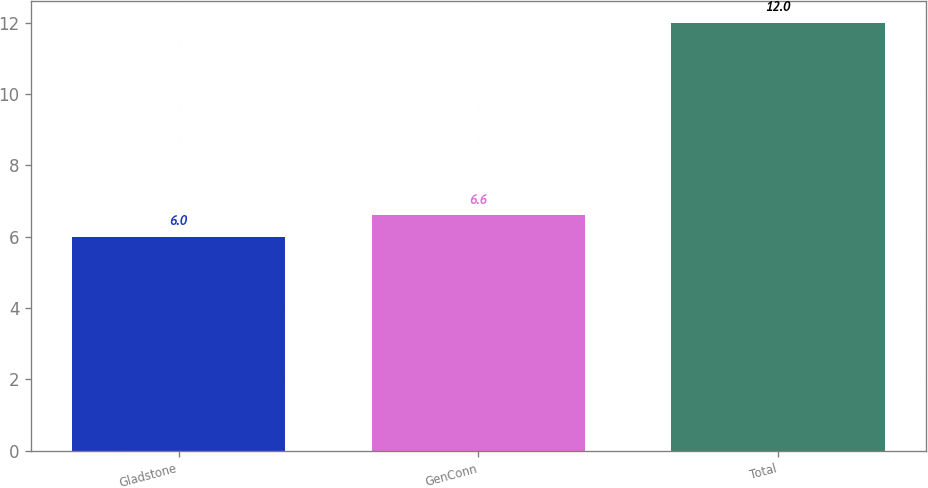Convert chart. <chart><loc_0><loc_0><loc_500><loc_500><bar_chart><fcel>Gladstone<fcel>GenConn<fcel>Total<nl><fcel>6<fcel>6.6<fcel>12<nl></chart> 